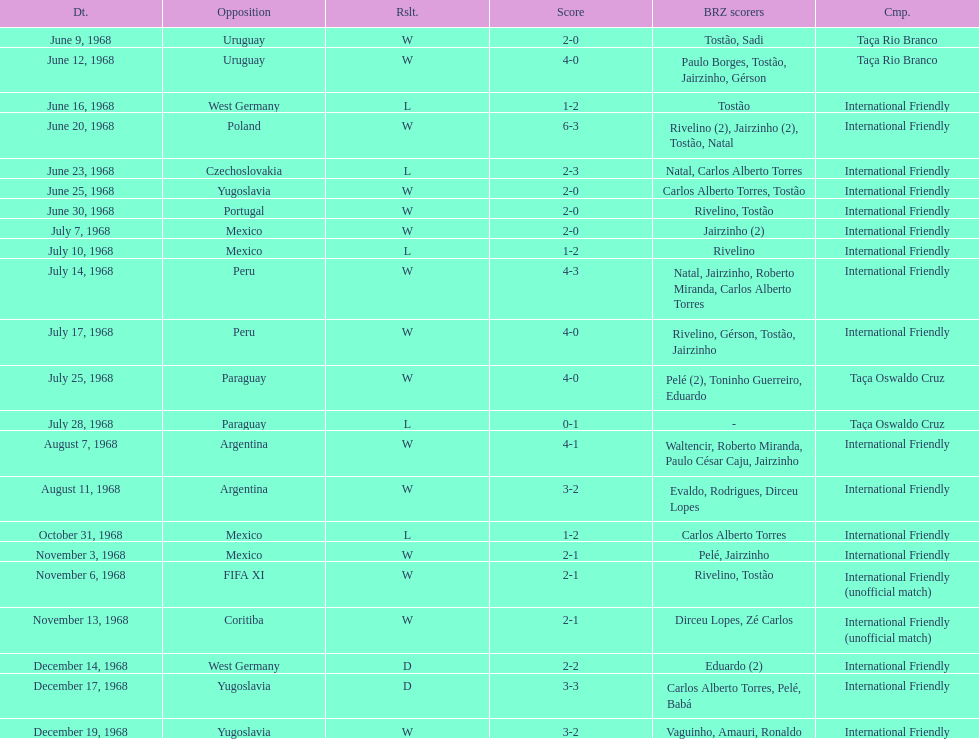What is the top score ever scored by the brazil national team? 6. 